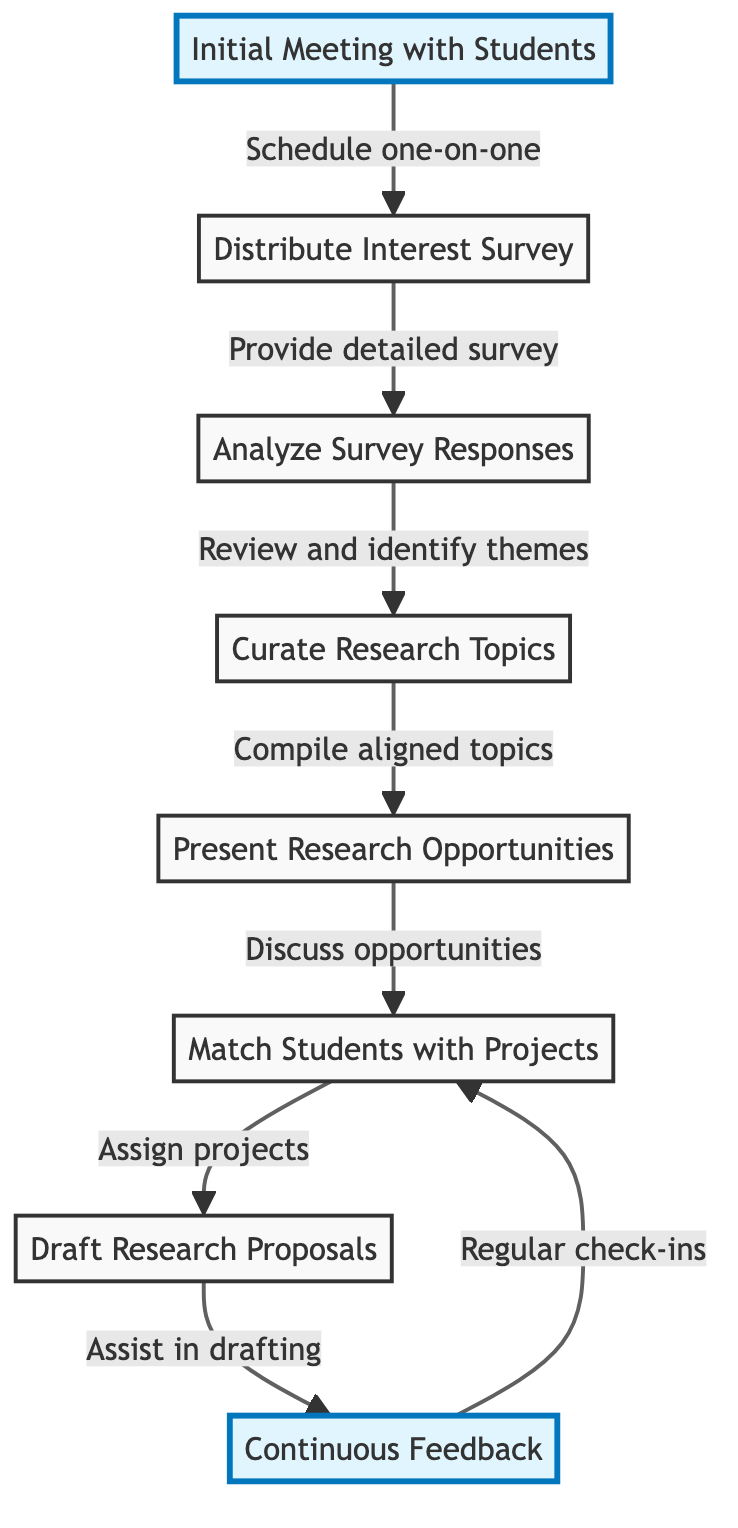What is the first step in the process? The first step is labeled as "Initial Meeting with Students," which is the starting point of the flowchart indicated by node 1.
Answer: Initial Meeting with Students How many total steps are in the process? There are 8 steps represented by the nodes in the flowchart, from the Initial Meeting to Continuous Feedback.
Answer: 8 What is the last step in the workflow? The last step is "Continuous Feedback," which is the final action indicated by node 8 in the flowchart.
Answer: Continuous Feedback Which step comes after "Curate Research Topics"? The step that follows "Curate Research Topics," indicated by node 4, is "Present Research Opportunities," represented by node 5.
Answer: Present Research Opportunities What is the relationship between "Analyze Survey Responses" and "Curate Research Topics"? The relationship indicates that after analyzing the survey responses (node 3), the next action is to curate research topics (node 4), demonstrating a flow from one task to the next.
Answer: Curate Research Topics Which two nodes are highlighted in the diagram? The two nodes highlighted in the diagram are "Initial Meeting with Students" and "Continuous Feedback," indicating their importance in the process.
Answer: Initial Meeting with Students, Continuous Feedback How does a student get matched with a project? A student gets matched with a project after "Present Research Opportunities" where discussions occur to assign them to research projects that align with their interests, which is processively reflected in node 6.
Answer: Match Students with Projects What type of feedback is provided during the "Continuous Feedback" step? The "Continuous Feedback" step signifies that regular check-ins will be taken to provide feedback on students' progress, ensuring alignment with their research goals.
Answer: Regular check-ins What is the immediate preceding step before "Draft Research Proposals"? The immediate preceding step before "Draft Research Proposals" (node 7) is "Match Students with Projects" (node 6), facilitating project assignment.
Answer: Match Students with Projects 